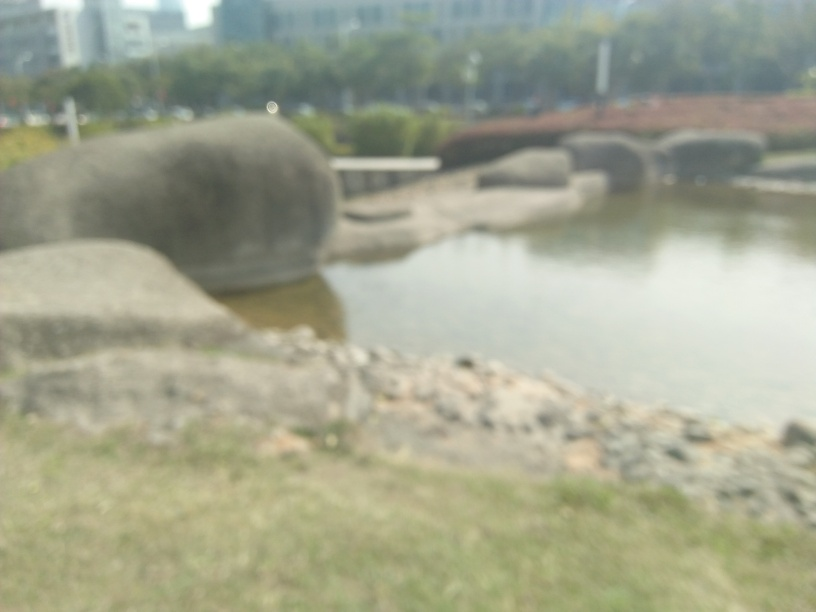Is the overall quality of the image good? While the question is subjective to personal taste and requirements for image quality, based on common photography standards, the image is not of good quality due to being noticeably blurred, which obscures detail and reduces the ability to analyze or appreciate the depicted scene. 